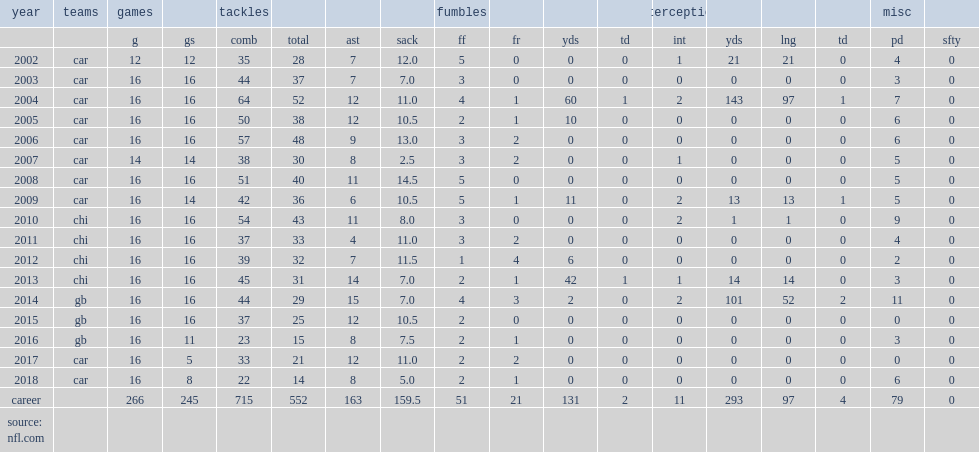How many tackles did peppers get in 2017? 32.0. 